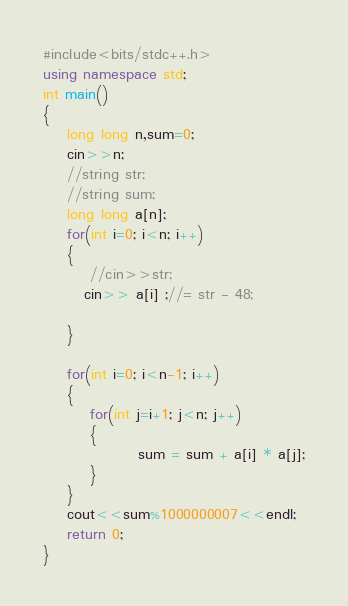Convert code to text. <code><loc_0><loc_0><loc_500><loc_500><_C++_>#include<bits/stdc++.h>
using namespace std;
int main()
{
    long long n,sum=0;
    cin>>n;
    //string str;
    //string sum;
    long long a[n];
    for(int i=0; i<n; i++)
    {
        //cin>>str;
       cin>> a[i] ;//= str - 48;

    }

    for(int i=0; i<n-1; i++)
    {
        for(int j=i+1; j<n; j++)
        {
                sum = sum + a[i] * a[j];
        }
    }
    cout<<sum%1000000007<<endl;
    return 0;
}
</code> 